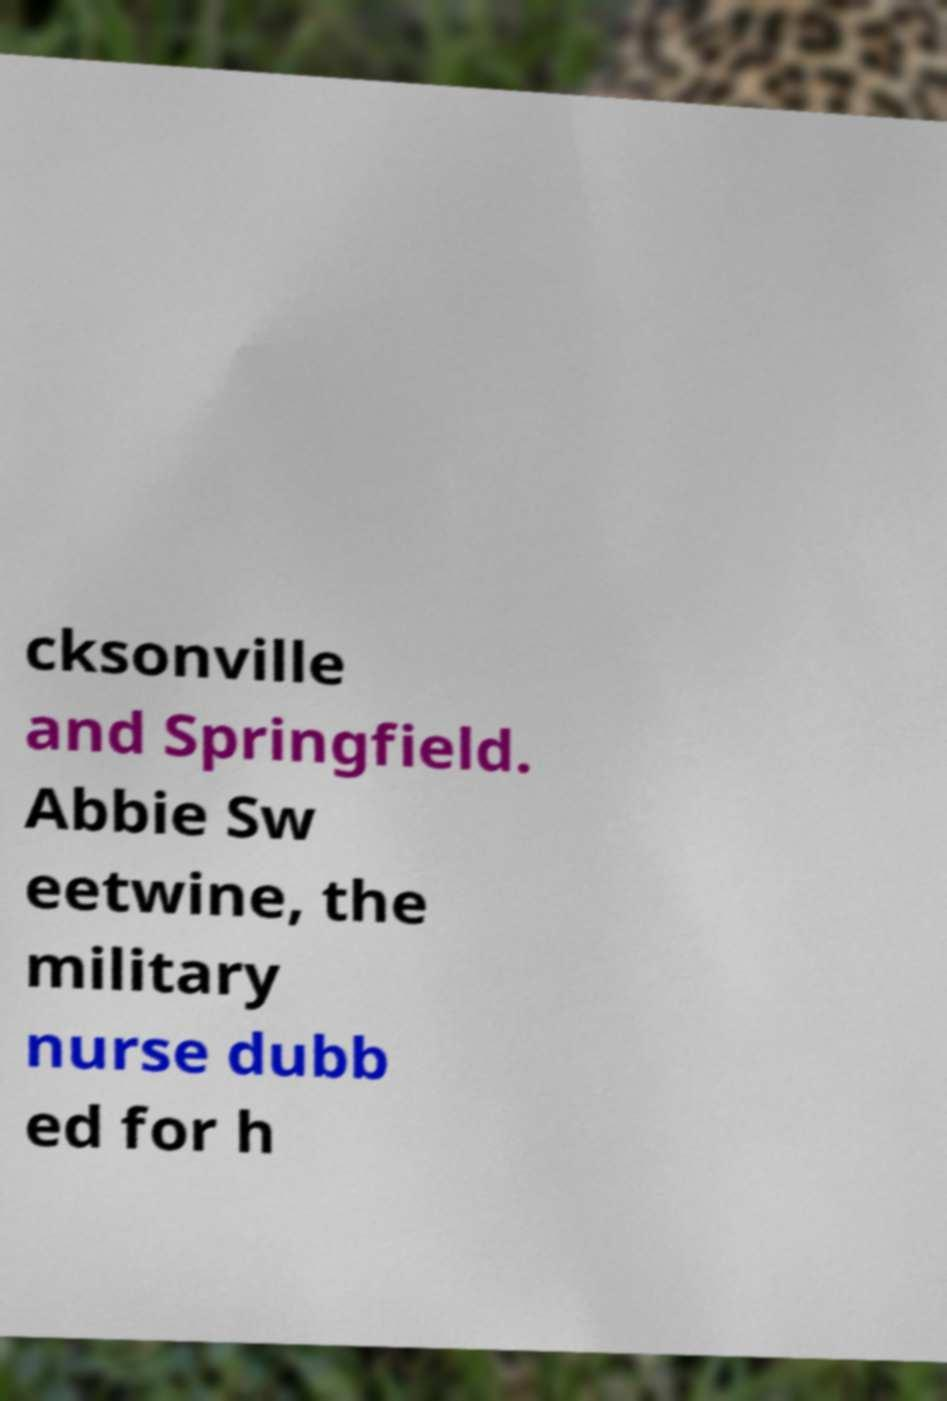I need the written content from this picture converted into text. Can you do that? cksonville and Springfield. Abbie Sw eetwine, the military nurse dubb ed for h 